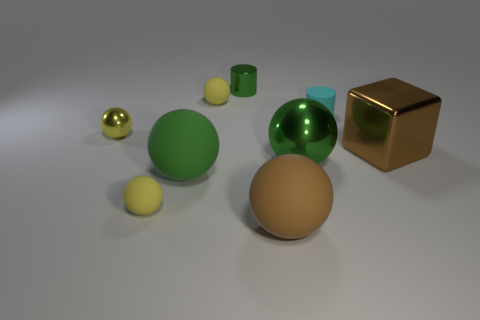Subtract all green cylinders. How many yellow balls are left? 3 Subtract all large green balls. How many balls are left? 4 Subtract all brown spheres. How many spheres are left? 5 Subtract all gray balls. Subtract all red cylinders. How many balls are left? 6 Add 1 yellow balls. How many objects exist? 10 Subtract all cubes. How many objects are left? 8 Subtract all small brown matte balls. Subtract all yellow balls. How many objects are left? 6 Add 7 big brown cubes. How many big brown cubes are left? 8 Add 1 big blue rubber things. How many big blue rubber things exist? 1 Subtract 0 purple spheres. How many objects are left? 9 